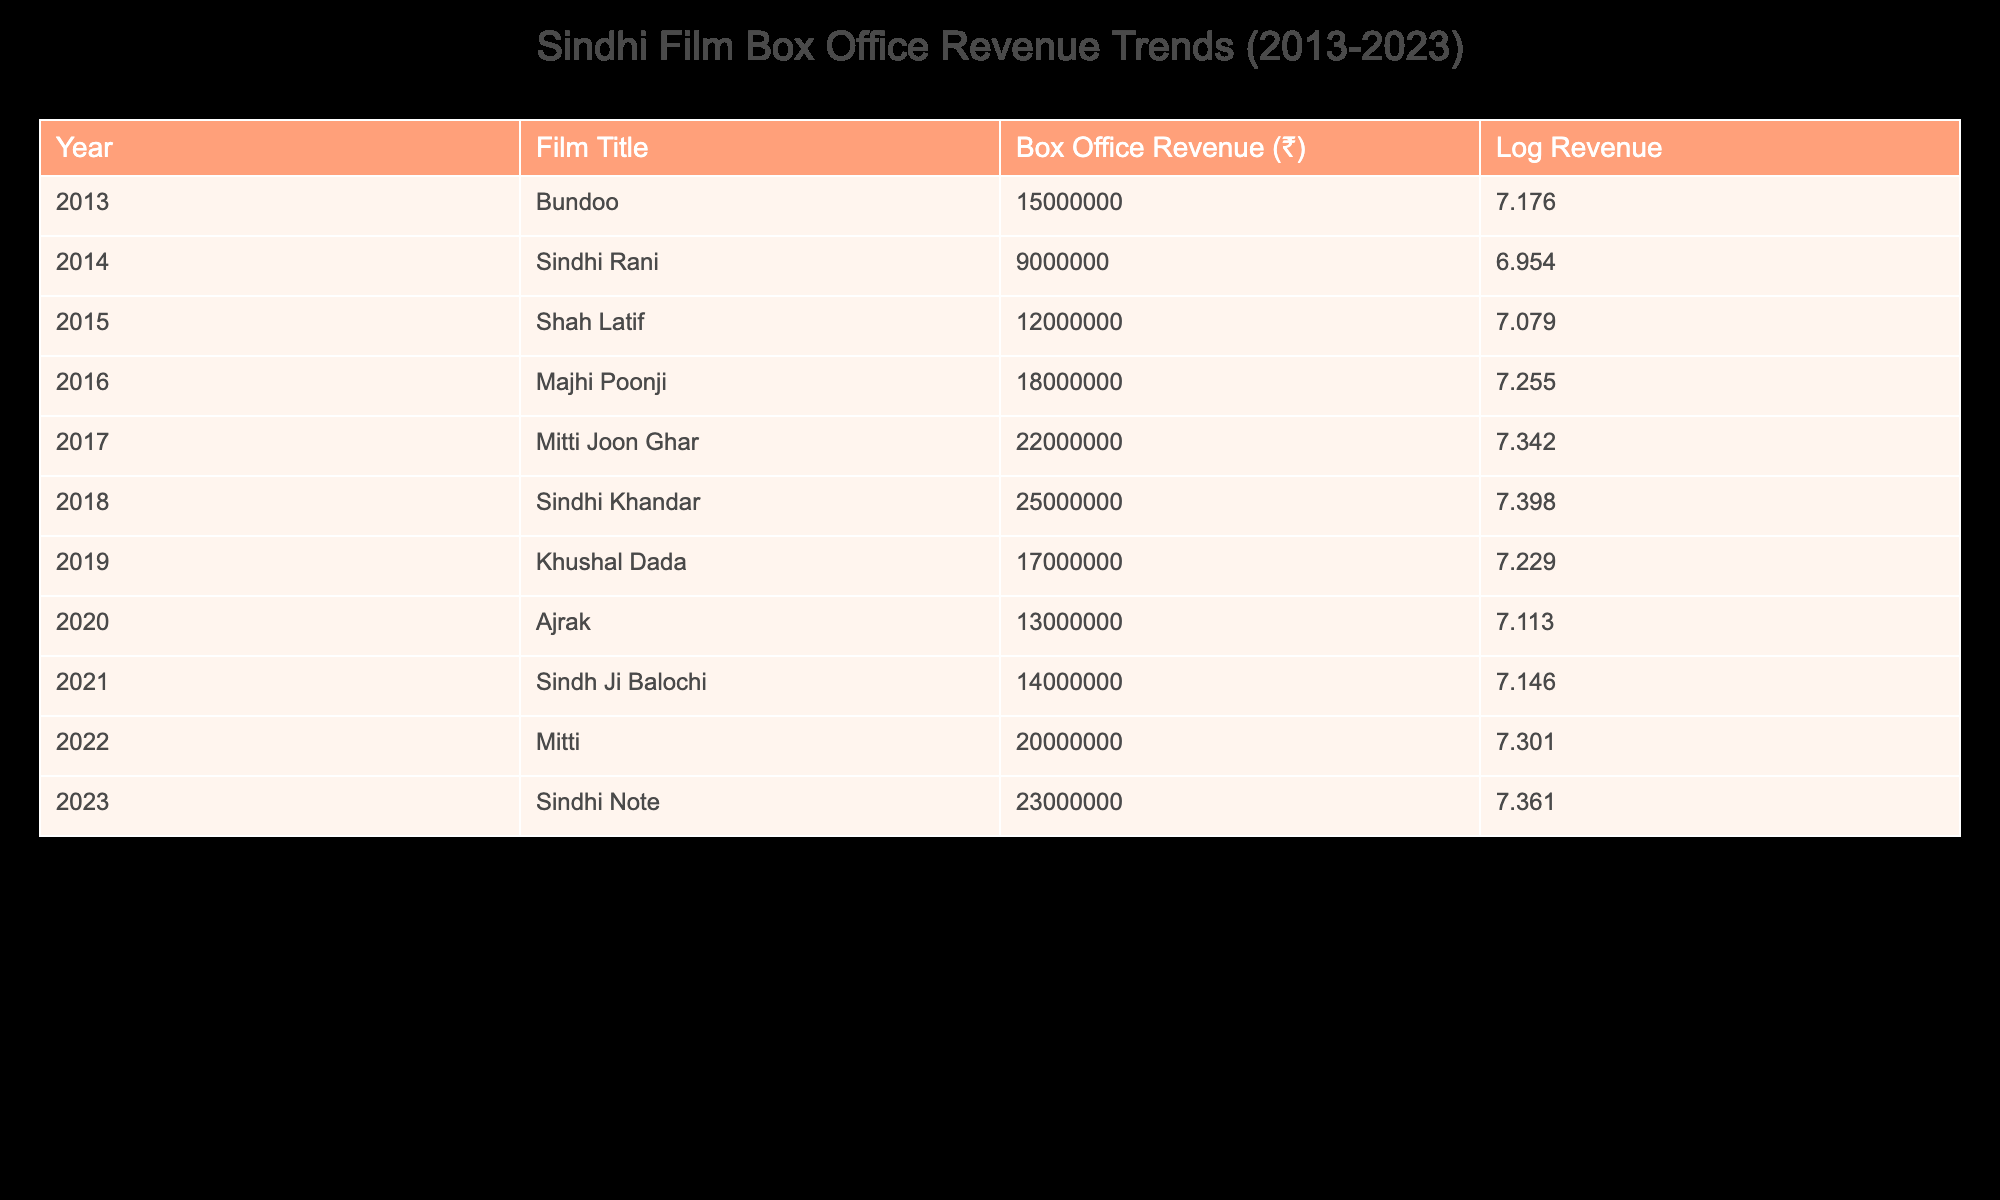What was the box office revenue of "Sindhi Khandar"? The table indicates that "Sindhi Khandar" was released in 2018, and its box office revenue was ₹25,000,000.
Answer: ₹25,000,000 Which film had the highest box office revenue in 2023? According to the table, the film released in 2023 is "Sindhi Note," which generated a box office revenue of ₹23,000,000, making it the highest for that year.
Answer: ₹23,000,000 What is the average box office revenue for the films from 2013 to 2023? To find the average, first, sum the box office revenues: 15000000 + 9000000 + 12000000 + 18000000 + 22000000 + 25000000 + 17000000 + 13000000 + 14000000 + 20000000 + 23000000 = ₹187,000,000. Then, divide by the number of films (11), which gives ₹187,000,000 / 11 ≈ ₹17,000,000.
Answer: ₹17,000,000 Did the box office revenue increase every year from 2013 to 2023? By reviewing the table year by year, the revenues do not consistently increase; for instance, revenue decreased from 2019 to 2020, from ₹17,000,000 to ₹13,000,000. Thus, it is false that the revenue increased every year.
Answer: No What is the difference in box office revenue between "Mitti Joon Ghar" (2017) and "Ajrak" (2020)? The revenue for "Mitti Joon Ghar" in 2017 is ₹22,000,000 and for "Ajrak" in 2020 is ₹13,000,000. The difference is ₹22,000,000 - ₹13,000,000 = ₹9,000,000.
Answer: ₹9,000,000 Which film had a log revenue greater than 7.3, and what was its revenue? From the table, the films with log revenue greater than 7.3 are "Sindhi Khandar" with a log revenue of 7.398 and a box office revenue of ₹25,000,000, "Sindhi Note" with a log revenue of 7.361 and revenue of ₹23,000,000, and "Mitti" with a log revenue of 7.301 and revenue of ₹20,000,000. The highest box office revenue among these is for "Sindhi Khandar" at ₹25,000,000.
Answer: ₹25,000,000 Has any film achieved a box office revenue of over ₹20,000,000 before 2020? Reviewing the table, the answer is yes; both "Mitti Joon Ghar" (2017, ₹22,000,000) and "Sindhi Khandar" (2018, ₹25,000,000) had box office revenues over ₹20,000,000 before 2020.
Answer: Yes What is the trend of box office revenues over the last decade based on the data? Analyzing the table, the trend shows an overall increase in the box office revenues with notable gains in 2016 and 2018. The revenue reached its peak with "Sindhi Khandar" in 2018, followed by a slight decrease in 2019 but rebounded to higher values in 2021 and 2023.
Answer: Increasing with peaks in 2018 and 2023 